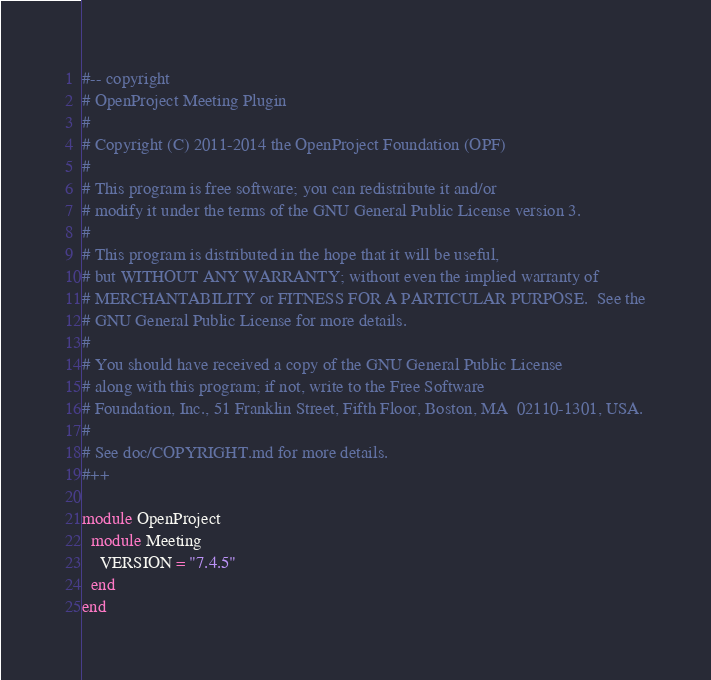Convert code to text. <code><loc_0><loc_0><loc_500><loc_500><_Ruby_>#-- copyright
# OpenProject Meeting Plugin
#
# Copyright (C) 2011-2014 the OpenProject Foundation (OPF)
#
# This program is free software; you can redistribute it and/or
# modify it under the terms of the GNU General Public License version 3.
#
# This program is distributed in the hope that it will be useful,
# but WITHOUT ANY WARRANTY; without even the implied warranty of
# MERCHANTABILITY or FITNESS FOR A PARTICULAR PURPOSE.  See the
# GNU General Public License for more details.
#
# You should have received a copy of the GNU General Public License
# along with this program; if not, write to the Free Software
# Foundation, Inc., 51 Franklin Street, Fifth Floor, Boston, MA  02110-1301, USA.
#
# See doc/COPYRIGHT.md for more details.
#++

module OpenProject
  module Meeting
    VERSION = "7.4.5"
  end
end
</code> 